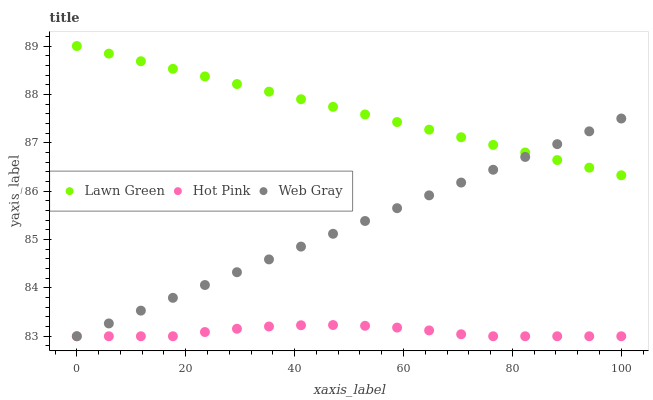Does Hot Pink have the minimum area under the curve?
Answer yes or no. Yes. Does Lawn Green have the maximum area under the curve?
Answer yes or no. Yes. Does Web Gray have the minimum area under the curve?
Answer yes or no. No. Does Web Gray have the maximum area under the curve?
Answer yes or no. No. Is Lawn Green the smoothest?
Answer yes or no. Yes. Is Hot Pink the roughest?
Answer yes or no. Yes. Is Web Gray the smoothest?
Answer yes or no. No. Is Web Gray the roughest?
Answer yes or no. No. Does Hot Pink have the lowest value?
Answer yes or no. Yes. Does Lawn Green have the highest value?
Answer yes or no. Yes. Does Web Gray have the highest value?
Answer yes or no. No. Is Hot Pink less than Lawn Green?
Answer yes or no. Yes. Is Lawn Green greater than Hot Pink?
Answer yes or no. Yes. Does Web Gray intersect Lawn Green?
Answer yes or no. Yes. Is Web Gray less than Lawn Green?
Answer yes or no. No. Is Web Gray greater than Lawn Green?
Answer yes or no. No. Does Hot Pink intersect Lawn Green?
Answer yes or no. No. 